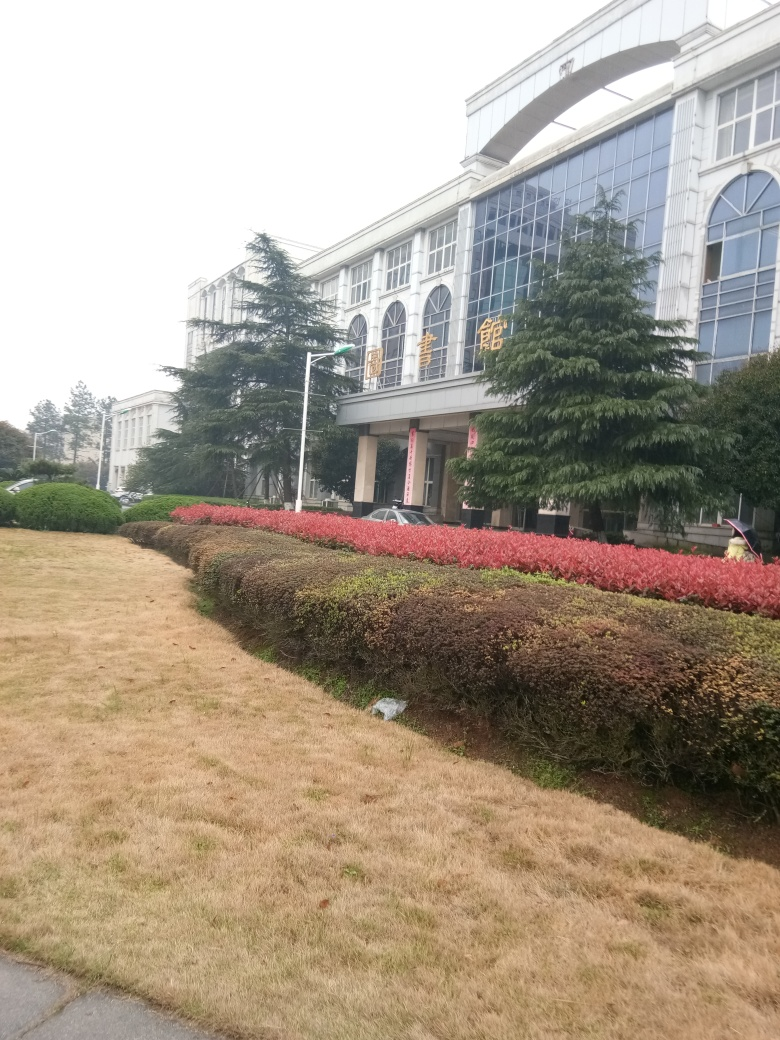What type of building is shown in this picture? The building in the image appears to be institutional or educational, characterized by its large size, symmetrical windows, and formal architecture. The banners suggest it may be a place of significance, possibly a university or government building. 